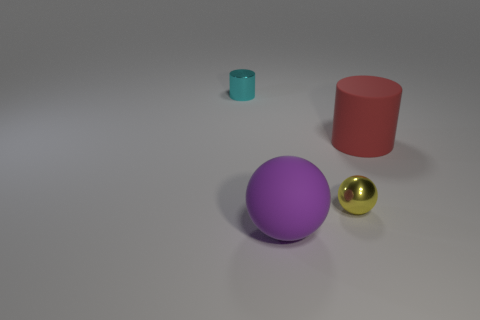Add 3 metal balls. How many objects exist? 7 Subtract all cyan cubes. Subtract all yellow spheres. How many objects are left? 3 Add 3 shiny spheres. How many shiny spheres are left? 4 Add 1 big purple metallic things. How many big purple metallic things exist? 1 Subtract 0 purple blocks. How many objects are left? 4 